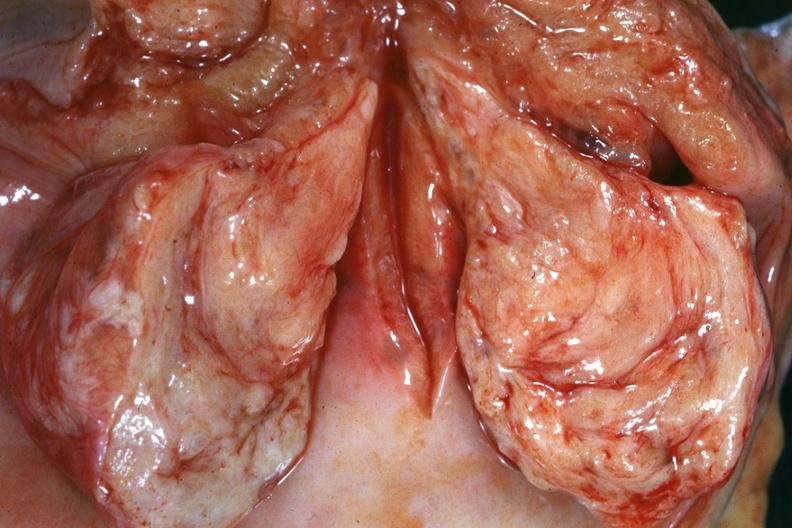what does this image show?
Answer the question using a single word or phrase. Close-up of cut surface of cervical myoma which is shown in relation to cervix and vagina 